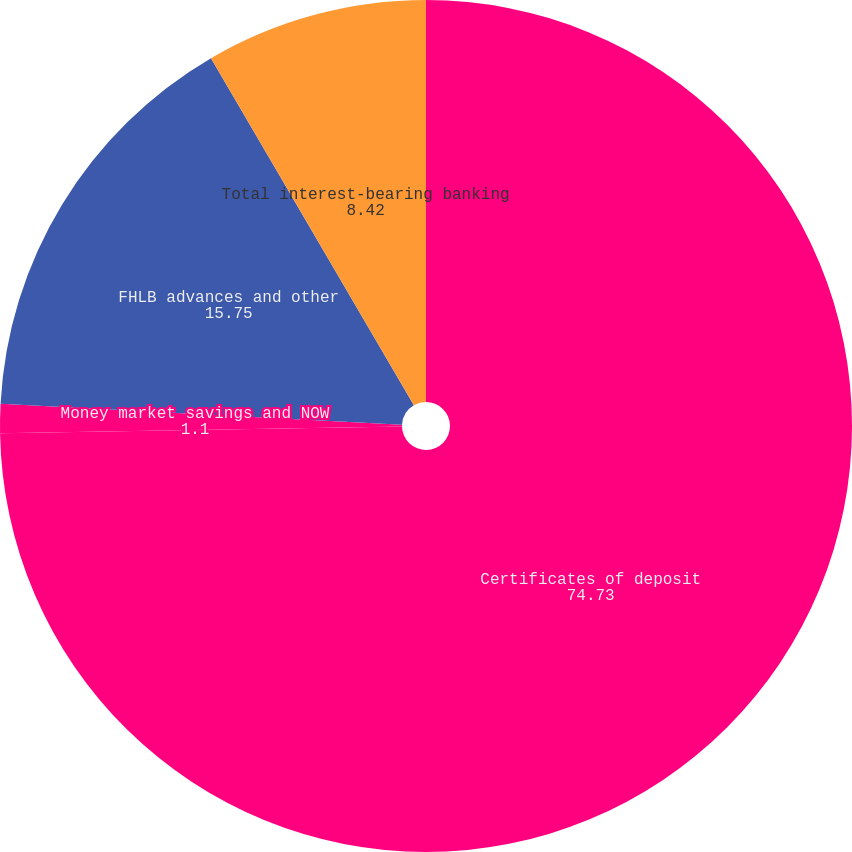<chart> <loc_0><loc_0><loc_500><loc_500><pie_chart><fcel>Certificates of deposit<fcel>Money market savings and NOW<fcel>FHLB advances and other<fcel>Total interest-bearing banking<nl><fcel>74.73%<fcel>1.1%<fcel>15.75%<fcel>8.42%<nl></chart> 